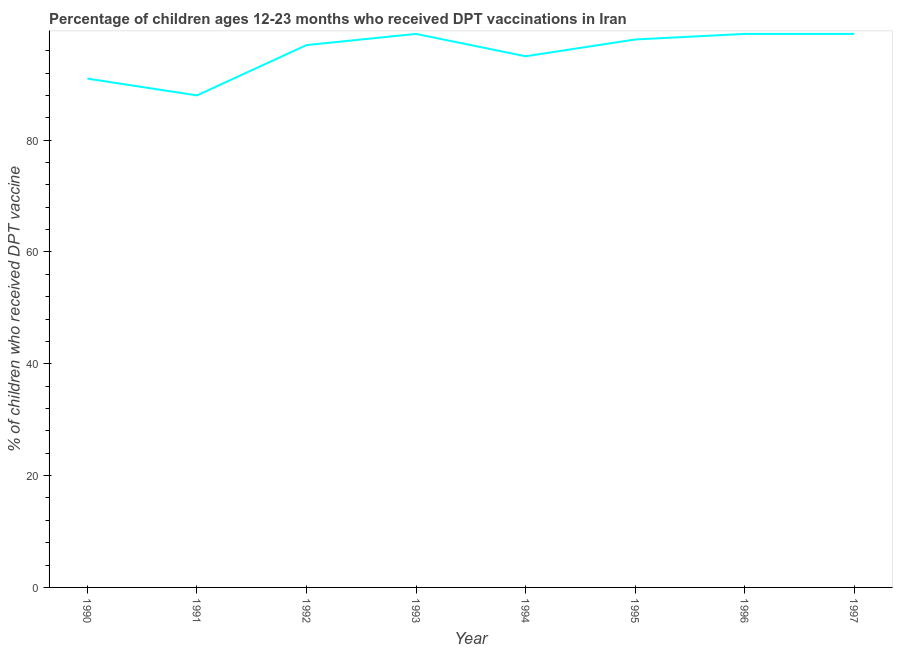What is the percentage of children who received dpt vaccine in 1997?
Your response must be concise. 99. Across all years, what is the maximum percentage of children who received dpt vaccine?
Keep it short and to the point. 99. Across all years, what is the minimum percentage of children who received dpt vaccine?
Offer a very short reply. 88. In which year was the percentage of children who received dpt vaccine maximum?
Ensure brevity in your answer.  1993. In which year was the percentage of children who received dpt vaccine minimum?
Make the answer very short. 1991. What is the sum of the percentage of children who received dpt vaccine?
Offer a very short reply. 766. What is the difference between the percentage of children who received dpt vaccine in 1990 and 1994?
Make the answer very short. -4. What is the average percentage of children who received dpt vaccine per year?
Give a very brief answer. 95.75. What is the median percentage of children who received dpt vaccine?
Give a very brief answer. 97.5. Do a majority of the years between 1996 and 1994 (inclusive) have percentage of children who received dpt vaccine greater than 92 %?
Your response must be concise. No. What is the ratio of the percentage of children who received dpt vaccine in 1990 to that in 1994?
Keep it short and to the point. 0.96. Is the percentage of children who received dpt vaccine in 1990 less than that in 1996?
Give a very brief answer. Yes. What is the difference between the highest and the lowest percentage of children who received dpt vaccine?
Give a very brief answer. 11. Does the percentage of children who received dpt vaccine monotonically increase over the years?
Offer a terse response. No. Are the values on the major ticks of Y-axis written in scientific E-notation?
Provide a succinct answer. No. Does the graph contain grids?
Make the answer very short. No. What is the title of the graph?
Your answer should be compact. Percentage of children ages 12-23 months who received DPT vaccinations in Iran. What is the label or title of the X-axis?
Make the answer very short. Year. What is the label or title of the Y-axis?
Give a very brief answer. % of children who received DPT vaccine. What is the % of children who received DPT vaccine of 1990?
Give a very brief answer. 91. What is the % of children who received DPT vaccine in 1991?
Keep it short and to the point. 88. What is the % of children who received DPT vaccine in 1992?
Provide a succinct answer. 97. What is the % of children who received DPT vaccine of 1993?
Give a very brief answer. 99. What is the % of children who received DPT vaccine of 1996?
Make the answer very short. 99. What is the % of children who received DPT vaccine in 1997?
Give a very brief answer. 99. What is the difference between the % of children who received DPT vaccine in 1990 and 1991?
Provide a short and direct response. 3. What is the difference between the % of children who received DPT vaccine in 1990 and 1995?
Keep it short and to the point. -7. What is the difference between the % of children who received DPT vaccine in 1990 and 1996?
Provide a succinct answer. -8. What is the difference between the % of children who received DPT vaccine in 1990 and 1997?
Your answer should be compact. -8. What is the difference between the % of children who received DPT vaccine in 1991 and 1997?
Give a very brief answer. -11. What is the difference between the % of children who received DPT vaccine in 1992 and 1994?
Keep it short and to the point. 2. What is the difference between the % of children who received DPT vaccine in 1992 and 1995?
Provide a succinct answer. -1. What is the difference between the % of children who received DPT vaccine in 1993 and 1995?
Provide a succinct answer. 1. What is the difference between the % of children who received DPT vaccine in 1994 and 1995?
Give a very brief answer. -3. What is the difference between the % of children who received DPT vaccine in 1994 and 1997?
Offer a very short reply. -4. What is the difference between the % of children who received DPT vaccine in 1996 and 1997?
Keep it short and to the point. 0. What is the ratio of the % of children who received DPT vaccine in 1990 to that in 1991?
Your response must be concise. 1.03. What is the ratio of the % of children who received DPT vaccine in 1990 to that in 1992?
Offer a terse response. 0.94. What is the ratio of the % of children who received DPT vaccine in 1990 to that in 1993?
Give a very brief answer. 0.92. What is the ratio of the % of children who received DPT vaccine in 1990 to that in 1994?
Give a very brief answer. 0.96. What is the ratio of the % of children who received DPT vaccine in 1990 to that in 1995?
Your answer should be very brief. 0.93. What is the ratio of the % of children who received DPT vaccine in 1990 to that in 1996?
Your response must be concise. 0.92. What is the ratio of the % of children who received DPT vaccine in 1990 to that in 1997?
Ensure brevity in your answer.  0.92. What is the ratio of the % of children who received DPT vaccine in 1991 to that in 1992?
Offer a terse response. 0.91. What is the ratio of the % of children who received DPT vaccine in 1991 to that in 1993?
Your response must be concise. 0.89. What is the ratio of the % of children who received DPT vaccine in 1991 to that in 1994?
Your answer should be very brief. 0.93. What is the ratio of the % of children who received DPT vaccine in 1991 to that in 1995?
Ensure brevity in your answer.  0.9. What is the ratio of the % of children who received DPT vaccine in 1991 to that in 1996?
Ensure brevity in your answer.  0.89. What is the ratio of the % of children who received DPT vaccine in 1991 to that in 1997?
Your answer should be very brief. 0.89. What is the ratio of the % of children who received DPT vaccine in 1992 to that in 1994?
Your response must be concise. 1.02. What is the ratio of the % of children who received DPT vaccine in 1992 to that in 1997?
Offer a very short reply. 0.98. What is the ratio of the % of children who received DPT vaccine in 1993 to that in 1994?
Offer a very short reply. 1.04. What is the ratio of the % of children who received DPT vaccine in 1993 to that in 1995?
Provide a short and direct response. 1.01. What is the ratio of the % of children who received DPT vaccine in 1993 to that in 1996?
Offer a very short reply. 1. What is the ratio of the % of children who received DPT vaccine in 1994 to that in 1996?
Your answer should be compact. 0.96. What is the ratio of the % of children who received DPT vaccine in 1995 to that in 1996?
Your response must be concise. 0.99. 